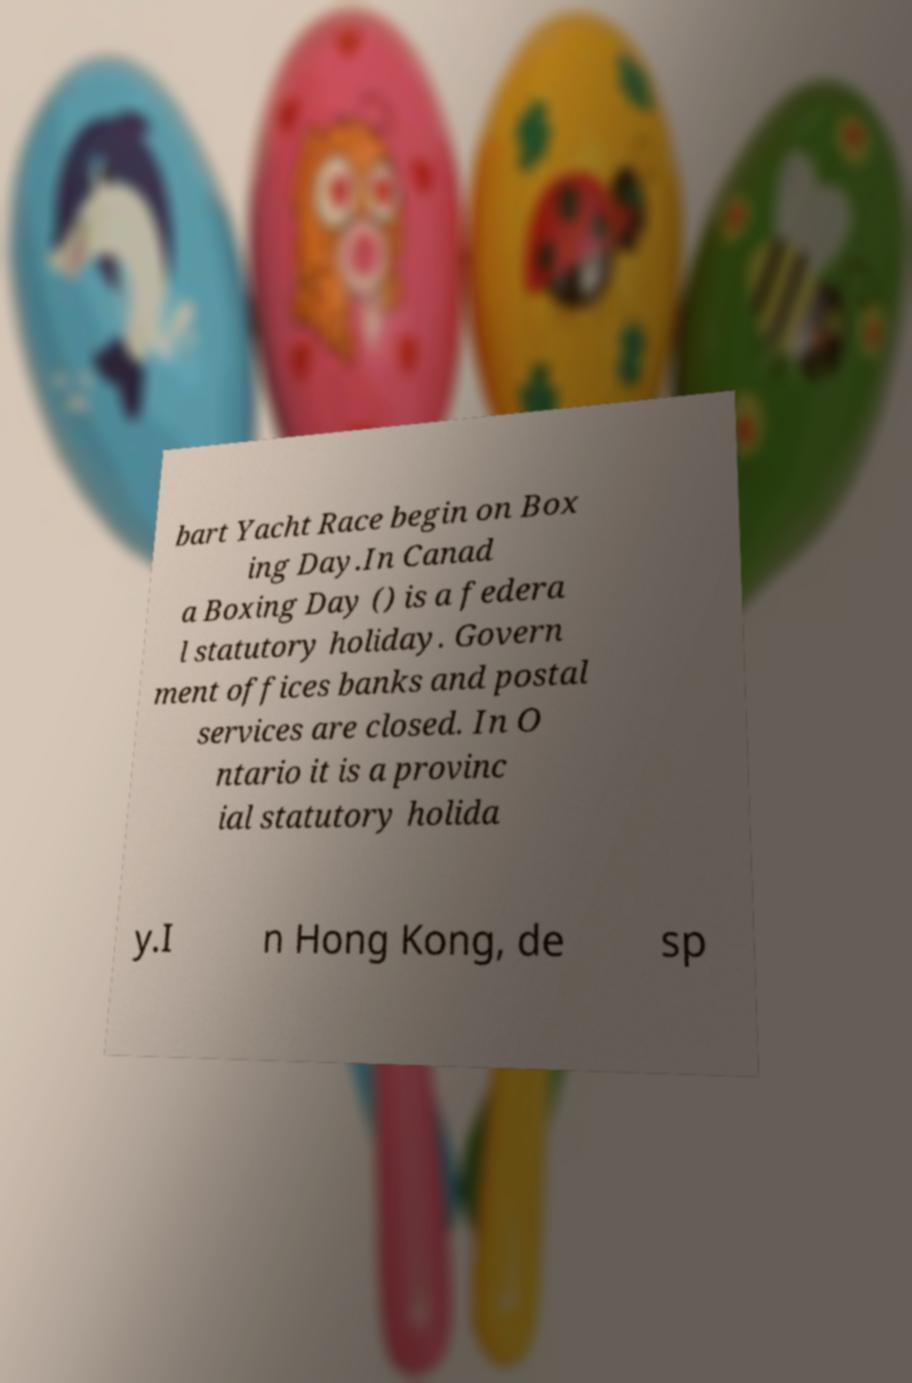What messages or text are displayed in this image? I need them in a readable, typed format. bart Yacht Race begin on Box ing Day.In Canad a Boxing Day () is a federa l statutory holiday. Govern ment offices banks and postal services are closed. In O ntario it is a provinc ial statutory holida y.I n Hong Kong, de sp 